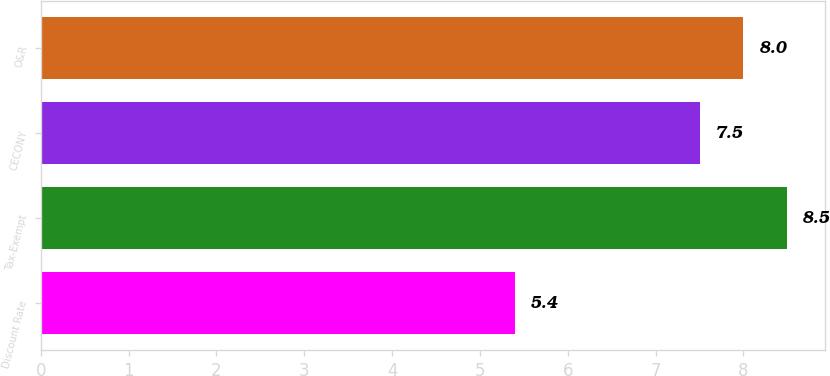Convert chart to OTSL. <chart><loc_0><loc_0><loc_500><loc_500><bar_chart><fcel>Discount Rate<fcel>Tax-Exempt<fcel>CECONY<fcel>O&R<nl><fcel>5.4<fcel>8.5<fcel>7.5<fcel>8<nl></chart> 